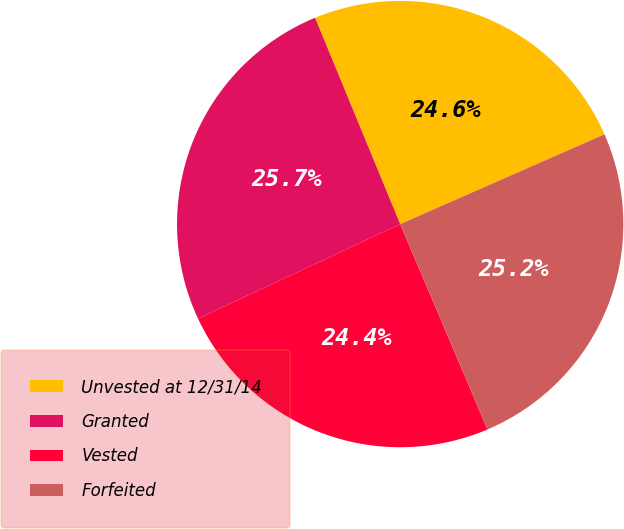Convert chart to OTSL. <chart><loc_0><loc_0><loc_500><loc_500><pie_chart><fcel>Unvested at 12/31/14<fcel>Granted<fcel>Vested<fcel>Forfeited<nl><fcel>24.64%<fcel>25.74%<fcel>24.43%<fcel>25.19%<nl></chart> 